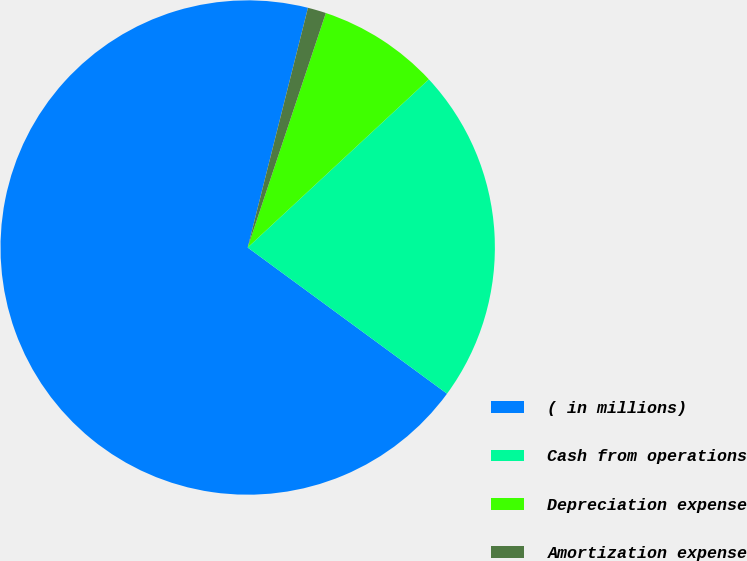<chart> <loc_0><loc_0><loc_500><loc_500><pie_chart><fcel>( in millions)<fcel>Cash from operations<fcel>Depreciation expense<fcel>Amortization expense<nl><fcel>68.85%<fcel>21.98%<fcel>7.97%<fcel>1.2%<nl></chart> 